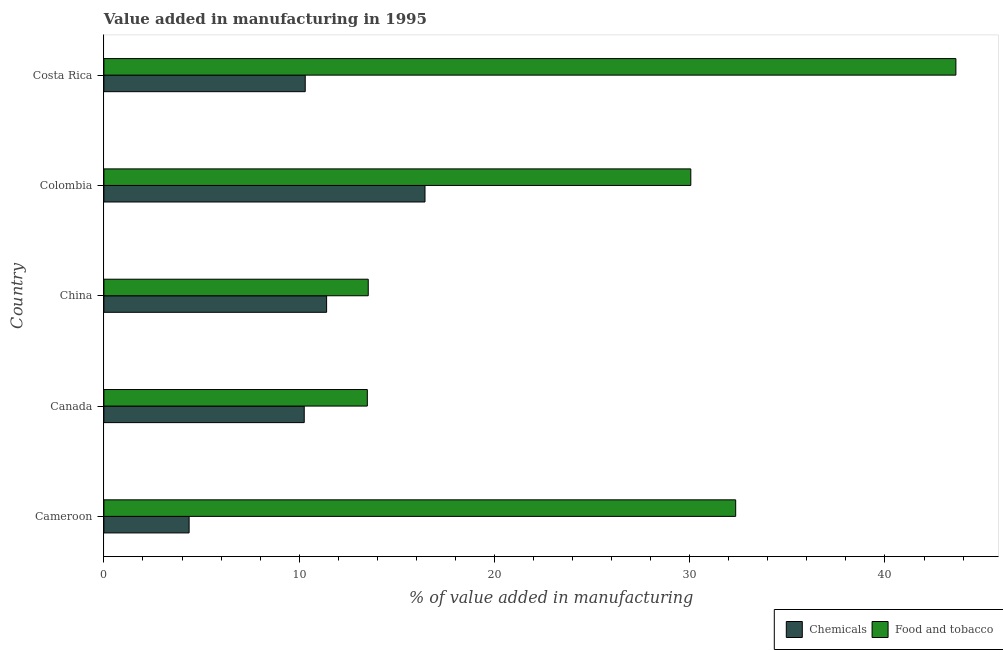How many groups of bars are there?
Your answer should be compact. 5. Are the number of bars per tick equal to the number of legend labels?
Offer a terse response. Yes. Are the number of bars on each tick of the Y-axis equal?
Give a very brief answer. Yes. In how many cases, is the number of bars for a given country not equal to the number of legend labels?
Offer a very short reply. 0. What is the value added by manufacturing food and tobacco in Canada?
Provide a short and direct response. 13.49. Across all countries, what is the maximum value added by manufacturing food and tobacco?
Your answer should be compact. 43.63. Across all countries, what is the minimum value added by manufacturing food and tobacco?
Offer a very short reply. 13.49. In which country was the value added by  manufacturing chemicals minimum?
Your answer should be compact. Cameroon. What is the total value added by manufacturing food and tobacco in the graph?
Keep it short and to the point. 133.08. What is the difference between the value added by manufacturing food and tobacco in Canada and that in China?
Ensure brevity in your answer.  -0.05. What is the difference between the value added by  manufacturing chemicals in Cameroon and the value added by manufacturing food and tobacco in Colombia?
Ensure brevity in your answer.  -25.69. What is the average value added by manufacturing food and tobacco per country?
Offer a very short reply. 26.61. What is the difference between the value added by manufacturing food and tobacco and value added by  manufacturing chemicals in Colombia?
Make the answer very short. 13.61. In how many countries, is the value added by manufacturing food and tobacco greater than 10 %?
Your answer should be compact. 5. What is the ratio of the value added by  manufacturing chemicals in Cameroon to that in Costa Rica?
Ensure brevity in your answer.  0.42. Is the value added by  manufacturing chemicals in Canada less than that in Colombia?
Your answer should be very brief. Yes. Is the difference between the value added by  manufacturing chemicals in China and Colombia greater than the difference between the value added by manufacturing food and tobacco in China and Colombia?
Offer a very short reply. Yes. What is the difference between the highest and the second highest value added by  manufacturing chemicals?
Offer a terse response. 5.04. What is the difference between the highest and the lowest value added by  manufacturing chemicals?
Provide a succinct answer. 12.08. In how many countries, is the value added by manufacturing food and tobacco greater than the average value added by manufacturing food and tobacco taken over all countries?
Offer a very short reply. 3. Is the sum of the value added by manufacturing food and tobacco in China and Costa Rica greater than the maximum value added by  manufacturing chemicals across all countries?
Give a very brief answer. Yes. What does the 1st bar from the top in Cameroon represents?
Your answer should be compact. Food and tobacco. What does the 1st bar from the bottom in Costa Rica represents?
Keep it short and to the point. Chemicals. Does the graph contain grids?
Your answer should be very brief. No. What is the title of the graph?
Make the answer very short. Value added in manufacturing in 1995. What is the label or title of the X-axis?
Provide a short and direct response. % of value added in manufacturing. What is the label or title of the Y-axis?
Offer a very short reply. Country. What is the % of value added in manufacturing of Chemicals in Cameroon?
Offer a very short reply. 4.36. What is the % of value added in manufacturing of Food and tobacco in Cameroon?
Your answer should be compact. 32.36. What is the % of value added in manufacturing of Chemicals in Canada?
Offer a terse response. 10.26. What is the % of value added in manufacturing in Food and tobacco in Canada?
Provide a succinct answer. 13.49. What is the % of value added in manufacturing of Chemicals in China?
Provide a succinct answer. 11.41. What is the % of value added in manufacturing in Food and tobacco in China?
Give a very brief answer. 13.54. What is the % of value added in manufacturing in Chemicals in Colombia?
Make the answer very short. 16.44. What is the % of value added in manufacturing of Food and tobacco in Colombia?
Offer a very short reply. 30.06. What is the % of value added in manufacturing of Chemicals in Costa Rica?
Keep it short and to the point. 10.31. What is the % of value added in manufacturing of Food and tobacco in Costa Rica?
Keep it short and to the point. 43.63. Across all countries, what is the maximum % of value added in manufacturing of Chemicals?
Make the answer very short. 16.44. Across all countries, what is the maximum % of value added in manufacturing of Food and tobacco?
Offer a terse response. 43.63. Across all countries, what is the minimum % of value added in manufacturing in Chemicals?
Provide a short and direct response. 4.36. Across all countries, what is the minimum % of value added in manufacturing in Food and tobacco?
Provide a short and direct response. 13.49. What is the total % of value added in manufacturing in Chemicals in the graph?
Your answer should be very brief. 52.79. What is the total % of value added in manufacturing in Food and tobacco in the graph?
Offer a very short reply. 133.08. What is the difference between the % of value added in manufacturing of Chemicals in Cameroon and that in Canada?
Give a very brief answer. -5.9. What is the difference between the % of value added in manufacturing in Food and tobacco in Cameroon and that in Canada?
Offer a very short reply. 18.86. What is the difference between the % of value added in manufacturing of Chemicals in Cameroon and that in China?
Offer a terse response. -7.04. What is the difference between the % of value added in manufacturing of Food and tobacco in Cameroon and that in China?
Make the answer very short. 18.82. What is the difference between the % of value added in manufacturing in Chemicals in Cameroon and that in Colombia?
Provide a short and direct response. -12.08. What is the difference between the % of value added in manufacturing in Food and tobacco in Cameroon and that in Colombia?
Ensure brevity in your answer.  2.3. What is the difference between the % of value added in manufacturing of Chemicals in Cameroon and that in Costa Rica?
Your answer should be compact. -5.95. What is the difference between the % of value added in manufacturing of Food and tobacco in Cameroon and that in Costa Rica?
Keep it short and to the point. -11.28. What is the difference between the % of value added in manufacturing of Chemicals in Canada and that in China?
Provide a succinct answer. -1.15. What is the difference between the % of value added in manufacturing in Food and tobacco in Canada and that in China?
Your answer should be compact. -0.05. What is the difference between the % of value added in manufacturing of Chemicals in Canada and that in Colombia?
Make the answer very short. -6.18. What is the difference between the % of value added in manufacturing in Food and tobacco in Canada and that in Colombia?
Keep it short and to the point. -16.57. What is the difference between the % of value added in manufacturing in Chemicals in Canada and that in Costa Rica?
Your answer should be very brief. -0.05. What is the difference between the % of value added in manufacturing in Food and tobacco in Canada and that in Costa Rica?
Ensure brevity in your answer.  -30.14. What is the difference between the % of value added in manufacturing in Chemicals in China and that in Colombia?
Ensure brevity in your answer.  -5.04. What is the difference between the % of value added in manufacturing of Food and tobacco in China and that in Colombia?
Offer a very short reply. -16.52. What is the difference between the % of value added in manufacturing of Chemicals in China and that in Costa Rica?
Your answer should be very brief. 1.09. What is the difference between the % of value added in manufacturing in Food and tobacco in China and that in Costa Rica?
Provide a succinct answer. -30.09. What is the difference between the % of value added in manufacturing of Chemicals in Colombia and that in Costa Rica?
Offer a terse response. 6.13. What is the difference between the % of value added in manufacturing of Food and tobacco in Colombia and that in Costa Rica?
Provide a succinct answer. -13.58. What is the difference between the % of value added in manufacturing of Chemicals in Cameroon and the % of value added in manufacturing of Food and tobacco in Canada?
Make the answer very short. -9.13. What is the difference between the % of value added in manufacturing in Chemicals in Cameroon and the % of value added in manufacturing in Food and tobacco in China?
Your response must be concise. -9.17. What is the difference between the % of value added in manufacturing in Chemicals in Cameroon and the % of value added in manufacturing in Food and tobacco in Colombia?
Keep it short and to the point. -25.69. What is the difference between the % of value added in manufacturing in Chemicals in Cameroon and the % of value added in manufacturing in Food and tobacco in Costa Rica?
Keep it short and to the point. -39.27. What is the difference between the % of value added in manufacturing of Chemicals in Canada and the % of value added in manufacturing of Food and tobacco in China?
Offer a terse response. -3.28. What is the difference between the % of value added in manufacturing of Chemicals in Canada and the % of value added in manufacturing of Food and tobacco in Colombia?
Your answer should be very brief. -19.8. What is the difference between the % of value added in manufacturing in Chemicals in Canada and the % of value added in manufacturing in Food and tobacco in Costa Rica?
Give a very brief answer. -33.37. What is the difference between the % of value added in manufacturing in Chemicals in China and the % of value added in manufacturing in Food and tobacco in Colombia?
Offer a terse response. -18.65. What is the difference between the % of value added in manufacturing of Chemicals in China and the % of value added in manufacturing of Food and tobacco in Costa Rica?
Your response must be concise. -32.23. What is the difference between the % of value added in manufacturing of Chemicals in Colombia and the % of value added in manufacturing of Food and tobacco in Costa Rica?
Your answer should be very brief. -27.19. What is the average % of value added in manufacturing in Chemicals per country?
Your answer should be compact. 10.56. What is the average % of value added in manufacturing in Food and tobacco per country?
Your response must be concise. 26.62. What is the difference between the % of value added in manufacturing in Chemicals and % of value added in manufacturing in Food and tobacco in Cameroon?
Keep it short and to the point. -27.99. What is the difference between the % of value added in manufacturing of Chemicals and % of value added in manufacturing of Food and tobacco in Canada?
Ensure brevity in your answer.  -3.23. What is the difference between the % of value added in manufacturing in Chemicals and % of value added in manufacturing in Food and tobacco in China?
Offer a terse response. -2.13. What is the difference between the % of value added in manufacturing of Chemicals and % of value added in manufacturing of Food and tobacco in Colombia?
Give a very brief answer. -13.61. What is the difference between the % of value added in manufacturing of Chemicals and % of value added in manufacturing of Food and tobacco in Costa Rica?
Your response must be concise. -33.32. What is the ratio of the % of value added in manufacturing of Chemicals in Cameroon to that in Canada?
Ensure brevity in your answer.  0.43. What is the ratio of the % of value added in manufacturing of Food and tobacco in Cameroon to that in Canada?
Ensure brevity in your answer.  2.4. What is the ratio of the % of value added in manufacturing of Chemicals in Cameroon to that in China?
Your answer should be compact. 0.38. What is the ratio of the % of value added in manufacturing in Food and tobacco in Cameroon to that in China?
Offer a terse response. 2.39. What is the ratio of the % of value added in manufacturing in Chemicals in Cameroon to that in Colombia?
Keep it short and to the point. 0.27. What is the ratio of the % of value added in manufacturing in Food and tobacco in Cameroon to that in Colombia?
Keep it short and to the point. 1.08. What is the ratio of the % of value added in manufacturing of Chemicals in Cameroon to that in Costa Rica?
Give a very brief answer. 0.42. What is the ratio of the % of value added in manufacturing of Food and tobacco in Cameroon to that in Costa Rica?
Provide a short and direct response. 0.74. What is the ratio of the % of value added in manufacturing in Chemicals in Canada to that in China?
Your answer should be very brief. 0.9. What is the ratio of the % of value added in manufacturing of Food and tobacco in Canada to that in China?
Your response must be concise. 1. What is the ratio of the % of value added in manufacturing of Chemicals in Canada to that in Colombia?
Keep it short and to the point. 0.62. What is the ratio of the % of value added in manufacturing of Food and tobacco in Canada to that in Colombia?
Ensure brevity in your answer.  0.45. What is the ratio of the % of value added in manufacturing in Chemicals in Canada to that in Costa Rica?
Give a very brief answer. 0.99. What is the ratio of the % of value added in manufacturing in Food and tobacco in Canada to that in Costa Rica?
Your response must be concise. 0.31. What is the ratio of the % of value added in manufacturing of Chemicals in China to that in Colombia?
Keep it short and to the point. 0.69. What is the ratio of the % of value added in manufacturing in Food and tobacco in China to that in Colombia?
Ensure brevity in your answer.  0.45. What is the ratio of the % of value added in manufacturing of Chemicals in China to that in Costa Rica?
Provide a succinct answer. 1.11. What is the ratio of the % of value added in manufacturing in Food and tobacco in China to that in Costa Rica?
Ensure brevity in your answer.  0.31. What is the ratio of the % of value added in manufacturing of Chemicals in Colombia to that in Costa Rica?
Your answer should be compact. 1.59. What is the ratio of the % of value added in manufacturing in Food and tobacco in Colombia to that in Costa Rica?
Provide a succinct answer. 0.69. What is the difference between the highest and the second highest % of value added in manufacturing in Chemicals?
Ensure brevity in your answer.  5.04. What is the difference between the highest and the second highest % of value added in manufacturing in Food and tobacco?
Offer a very short reply. 11.28. What is the difference between the highest and the lowest % of value added in manufacturing of Chemicals?
Provide a succinct answer. 12.08. What is the difference between the highest and the lowest % of value added in manufacturing of Food and tobacco?
Your answer should be compact. 30.14. 